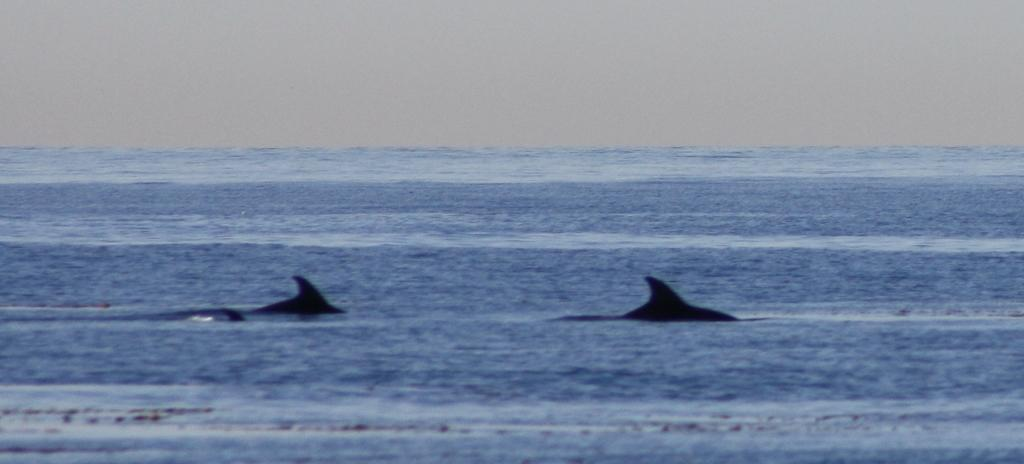What type of animals can be seen in the image? Dolphins can be seen in the image. What is the primary element in which the dolphins are situated? The dolphins are situated in water. What is visible at the top of the image? The sky is visible at the top of the image. What idea is being expressed in the note that is floating in the water? There is no note present in the image; it only features dolphins in the water and the sky visible at the top. 